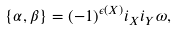<formula> <loc_0><loc_0><loc_500><loc_500>\{ \alpha , \beta \} = ( - 1 ) ^ { \epsilon ( X ) } i _ { X } i _ { Y } \omega ,</formula> 